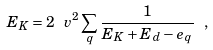<formula> <loc_0><loc_0><loc_500><loc_500>E _ { K } = 2 \ v ^ { 2 } \sum _ { q } \frac { 1 } { E _ { K } + E _ { d } - e _ { q } } \ ,</formula> 